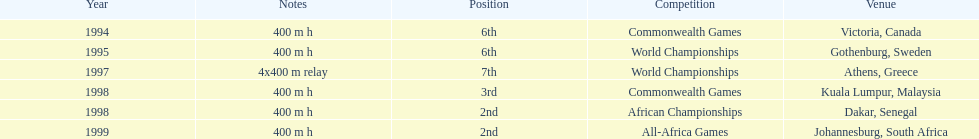Which year had the most competitions? 1998. Give me the full table as a dictionary. {'header': ['Year', 'Notes', 'Position', 'Competition', 'Venue'], 'rows': [['1994', '400 m h', '6th', 'Commonwealth Games', 'Victoria, Canada'], ['1995', '400 m h', '6th', 'World Championships', 'Gothenburg, Sweden'], ['1997', '4x400 m relay', '7th', 'World Championships', 'Athens, Greece'], ['1998', '400 m h', '3rd', 'Commonwealth Games', 'Kuala Lumpur, Malaysia'], ['1998', '400 m h', '2nd', 'African Championships', 'Dakar, Senegal'], ['1999', '400 m h', '2nd', 'All-Africa Games', 'Johannesburg, South Africa']]} 